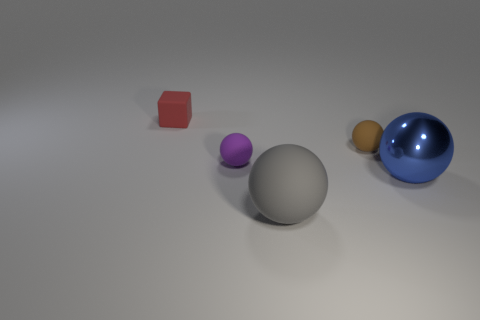What material is the tiny brown sphere?
Give a very brief answer. Rubber. What material is the small thing that is in front of the red matte thing and on the left side of the brown object?
Your response must be concise. Rubber. There is a rubber block; is its color the same as the thing in front of the large blue object?
Offer a terse response. No. What is the material of the other ball that is the same size as the blue shiny sphere?
Give a very brief answer. Rubber. Is there a large green block that has the same material as the gray thing?
Your answer should be very brief. No. What number of small blue cylinders are there?
Offer a very short reply. 0. Do the small brown object and the big sphere on the right side of the tiny brown object have the same material?
Make the answer very short. No. What number of other tiny cubes are the same color as the cube?
Your answer should be compact. 0. The red rubber block has what size?
Ensure brevity in your answer.  Small. There is a purple rubber object; does it have the same shape as the tiny thing that is to the left of the tiny purple object?
Provide a succinct answer. No. 